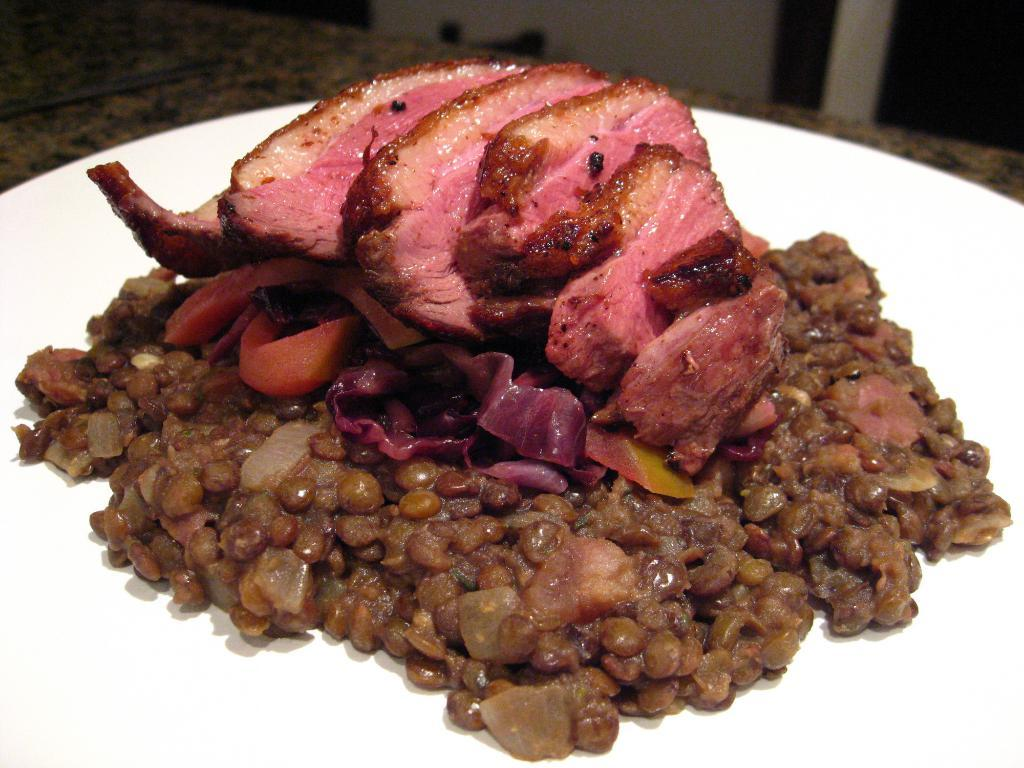What is the main subject in the foreground of the image? There is a food item in a plate in the foreground of the image. What type of furniture is visible in the image? There is a table visible at the top of the image. Can you describe any other objects present in the image? There are other objects present in the image, but their specific details are not mentioned in the provided facts. What type of vest is the food item wearing in the image? The food item is not wearing a vest, as it is an inanimate object and not capable of wearing clothing. 